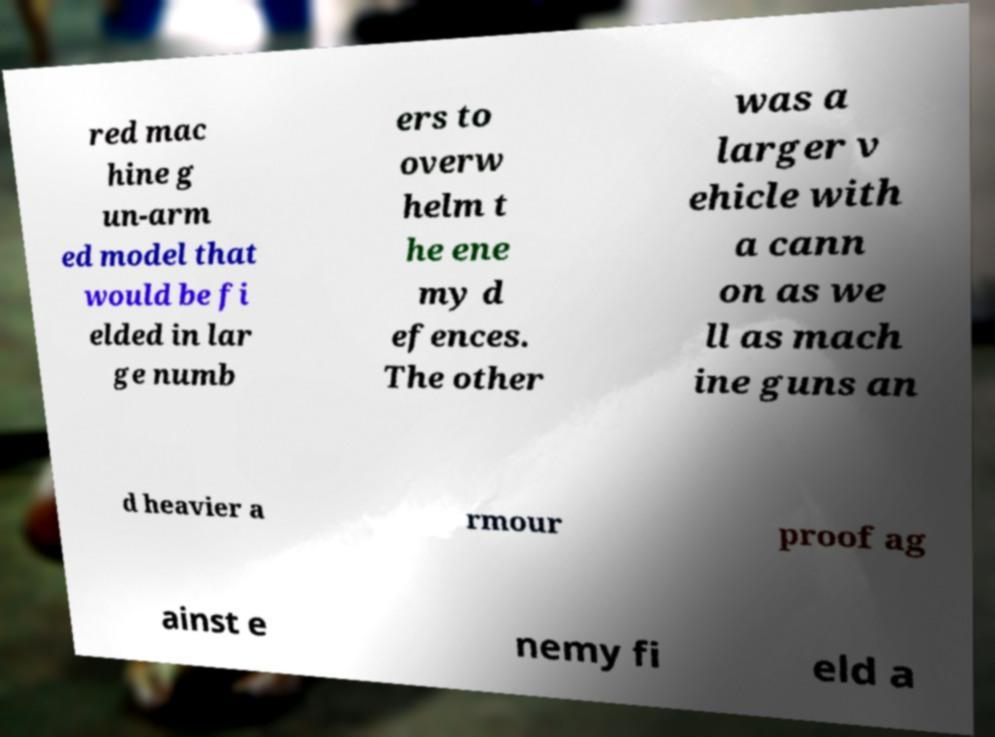What messages or text are displayed in this image? I need them in a readable, typed format. red mac hine g un-arm ed model that would be fi elded in lar ge numb ers to overw helm t he ene my d efences. The other was a larger v ehicle with a cann on as we ll as mach ine guns an d heavier a rmour proof ag ainst e nemy fi eld a 